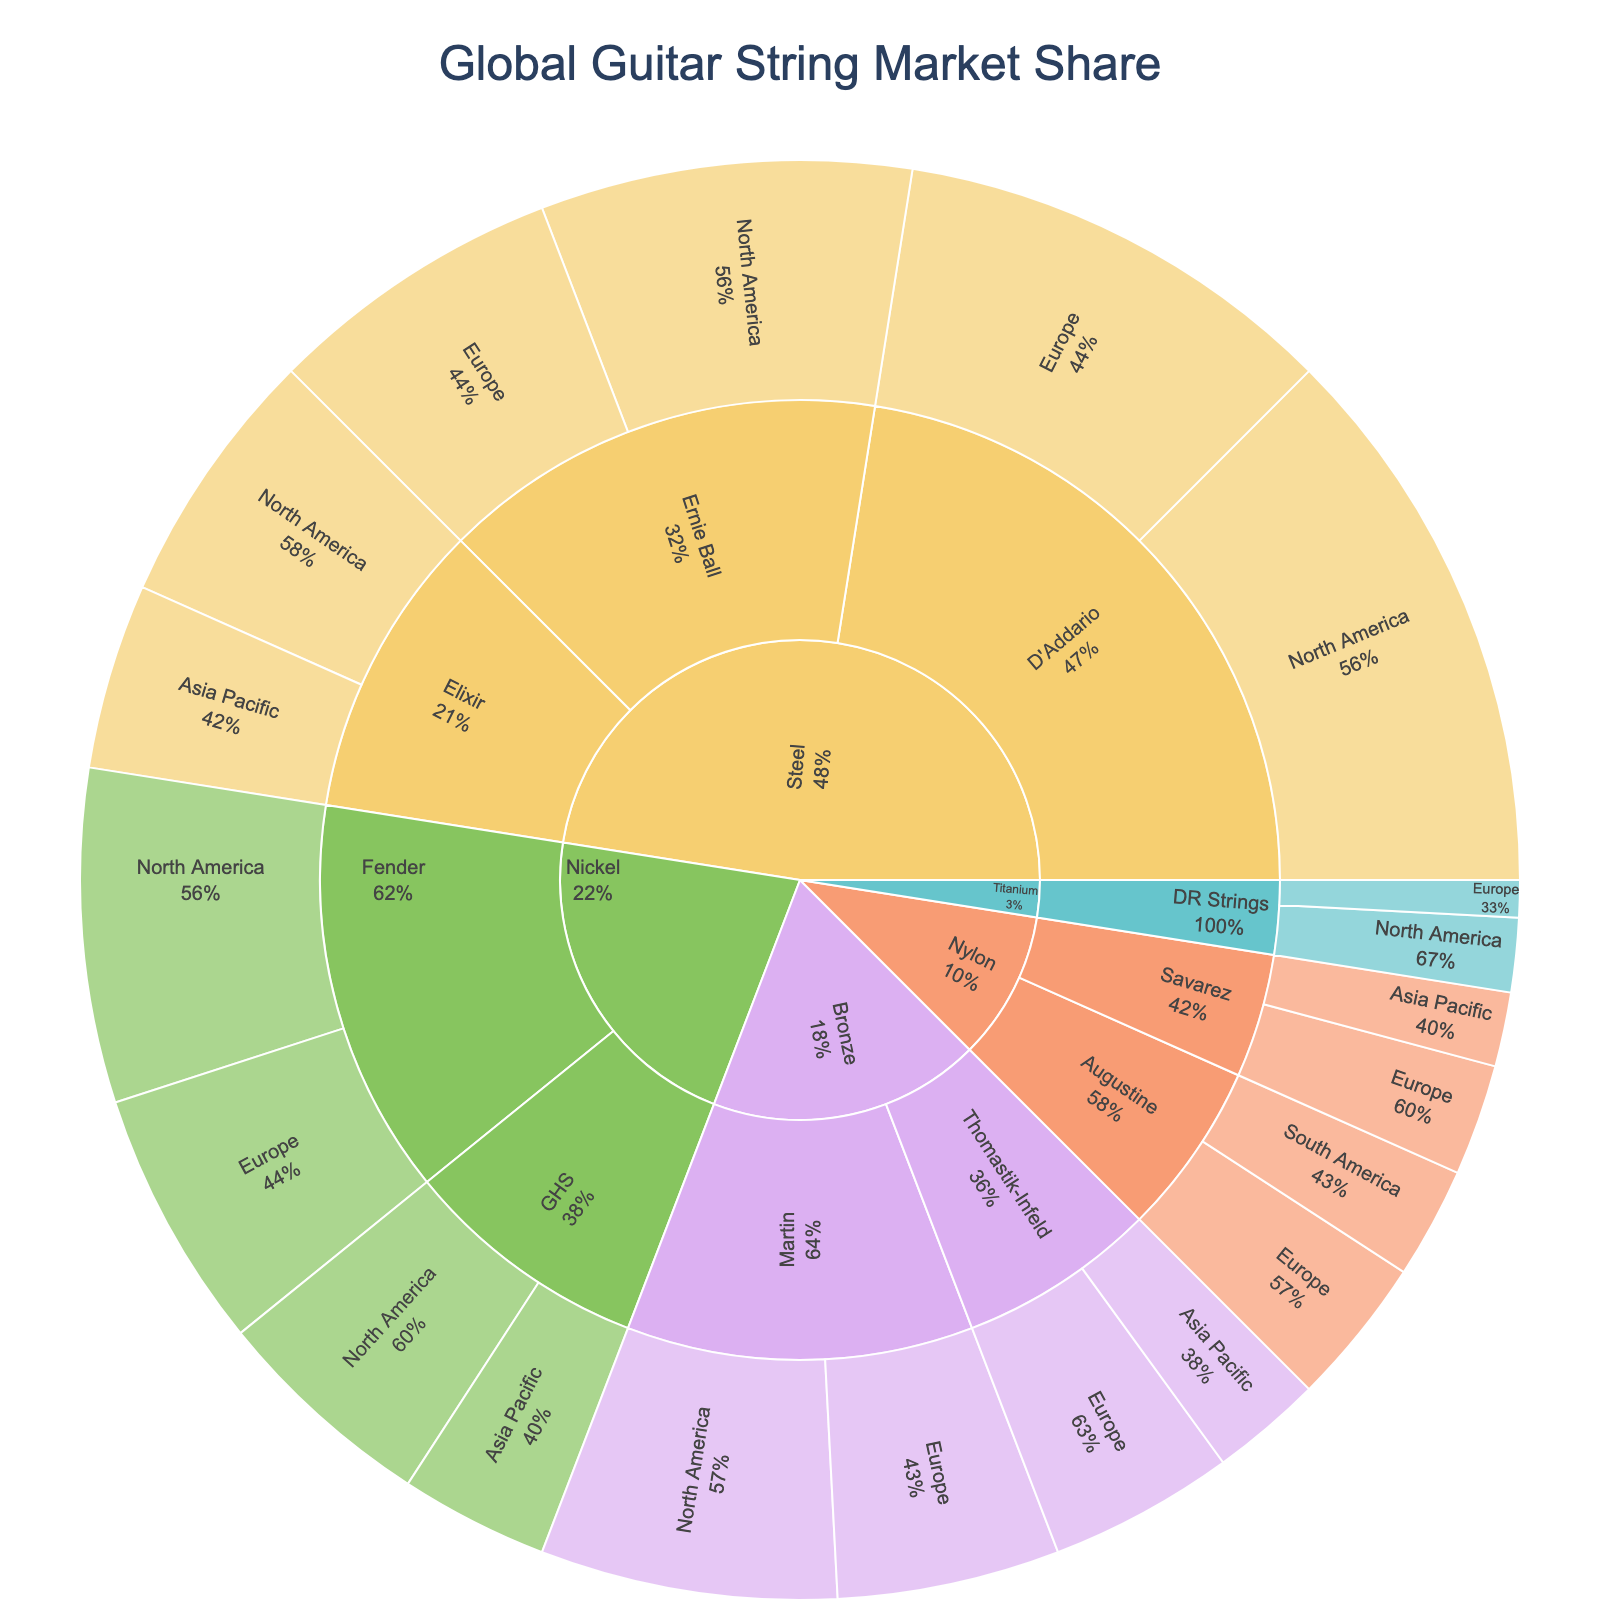What is the market share of Steel strings in North America? Find the section for Steel strings in North America, which includes D'Addario, Ernie Ball, and Elixir brands. Sum their market shares: 15 (D'Addario) + 10 (Ernie Ball) + 7 (Elixir) = 32
Answer: 32 Which region has the smallest market share for Nylon strings? Locate the sections for Nylon strings and compare their market shares in Europe (Augustine and Savarez total 4+3=7) and South America (3 for Augustine) and Asia Pacific (2 for Savarez). South America and Asia Pacific have 3% and 2%, respectively. The smallest is in Asia Pacific.
Answer: Asia Pacific Which brand has the highest market share within the Nickel material category? Find the sections for Nickel strings and sum the market shares for each brand: Fender (9 + 7 = 16) and GHS (6 + 4 = 10). Fender has the highest market share within Nickel.
Answer: Fender What is the combined market share of all Titanium strings? Locate the Titanium strings and sum up the market shares: 2 (North America) + 1 (Europe) = 3
Answer: 3 Which material type has the highest market share across all regions combined? Compare the total market share for each material: Steel (15 + 12 + 10 + 8 + 7 + 5 = 57), Nickel (9 + 7 + 6 + 4 = 26), Bronze (8 + 6 + 5 + 3 = 22), Nylon (4 + 3 + 3 + 2 = 12), Titanium (2 + 1 = 3). Steel has the highest market share.
Answer: Steel How does the market share of Bronze strings in Europe compare to North America? Find the Bronze string sections and compare market shares in Europe (Martin 6 + Thomastik-Infeld 5 = 11) and North America (8 for Martin). Europe has 11 and North America has 8. Europe is higher.
Answer: Europe has a higher market share What’s the percentage market share difference between D'Addario and Ernie Ball in Europe for Steel strings? Locate the Steel strings sections for D'Addario (12) and Ernie Ball (8) in Europe. The difference is 12 - 8 = 4. The total market share in Steel-Europe is 12 + 8 = 20, so the percentage difference is (4 / 20) * 100% = 20%
Answer: 20% What is the average market share for all brands in the Asia Pacific region? Sum total market shares in Asia Pacific (Elixir Steel 5 + GHS Nickel 4 + Thomastik-Infeld Bronze 3 + Savarez Nylon 2 = 14) and count the brands (4). The average market share is 14 / 4 = 3.5
Answer: 3.5 